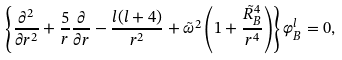<formula> <loc_0><loc_0><loc_500><loc_500>\left \{ { \frac { \partial ^ { 2 } } { \partial r ^ { 2 } } } + { \frac { 5 } { r } } { \frac { \partial } { \partial r } } - { \frac { l ( l + 4 ) } { r ^ { 2 } } } + \tilde { \omega } ^ { 2 } \left ( 1 + { \frac { \tilde { R } _ { B } ^ { 4 } } { r ^ { 4 } } } \right ) \right \} \varphi _ { B } ^ { l } = 0 ,</formula> 